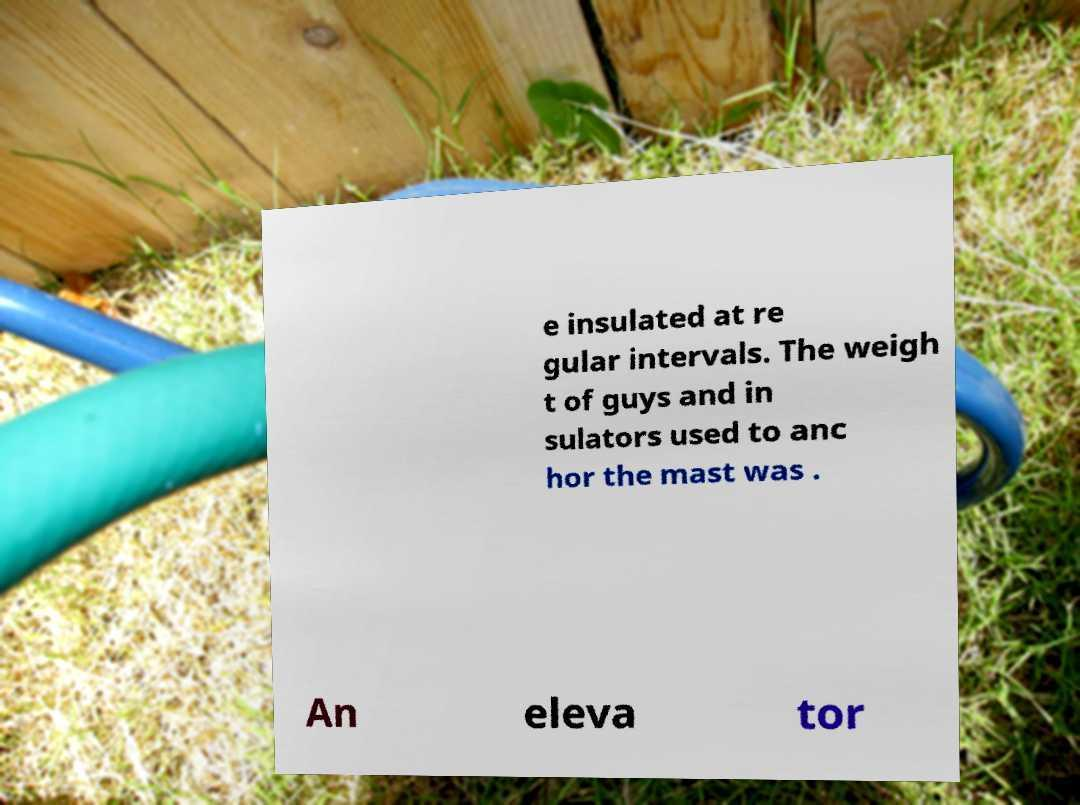There's text embedded in this image that I need extracted. Can you transcribe it verbatim? e insulated at re gular intervals. The weigh t of guys and in sulators used to anc hor the mast was . An eleva tor 